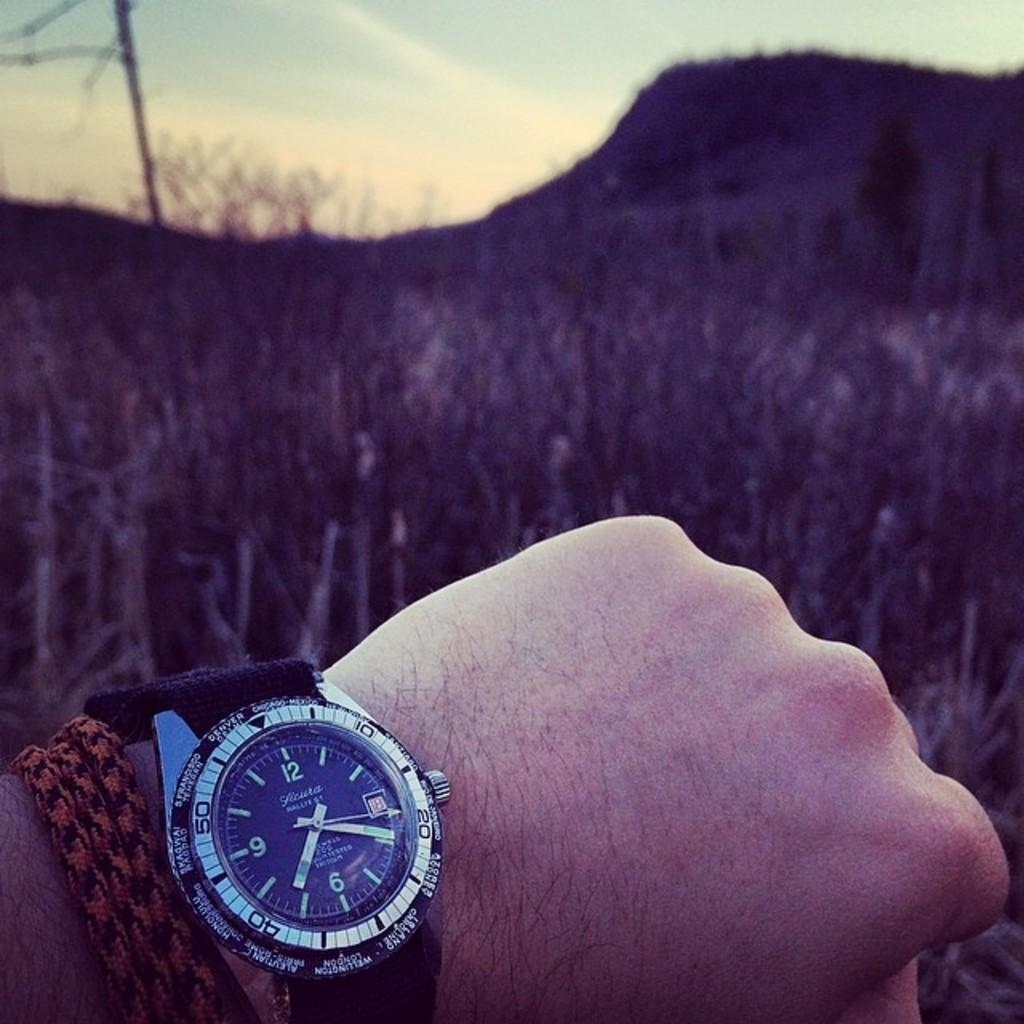<image>
Provide a brief description of the given image. Someone is wearing their watch that says it's the 18th and is standing by a field. 